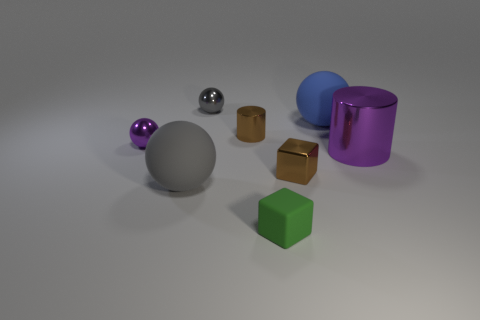There is a blue rubber sphere; how many large blue spheres are in front of it? 0 